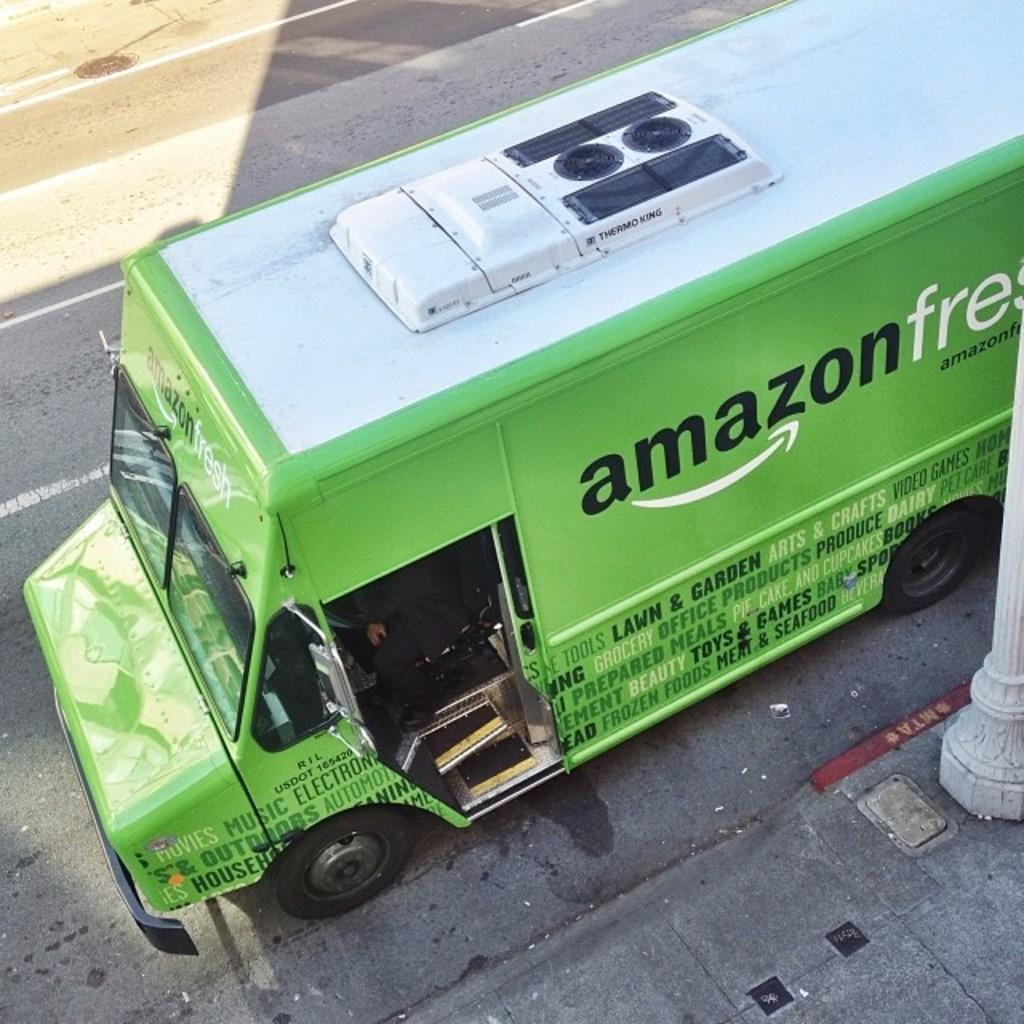What type of vehicle is in the image? There is a green bus in the image. What is at the bottom of the image? There is a road at the bottom of the image. What is beside the road? There is a pavement beside the road. What can be seen on the right side of the image? There is a pillar on the right side of the image. Can you touch the airplane in the image? There is no airplane present in the image, so it cannot be touched. Are there any bears visible in the image? There are no bears present in the image. 